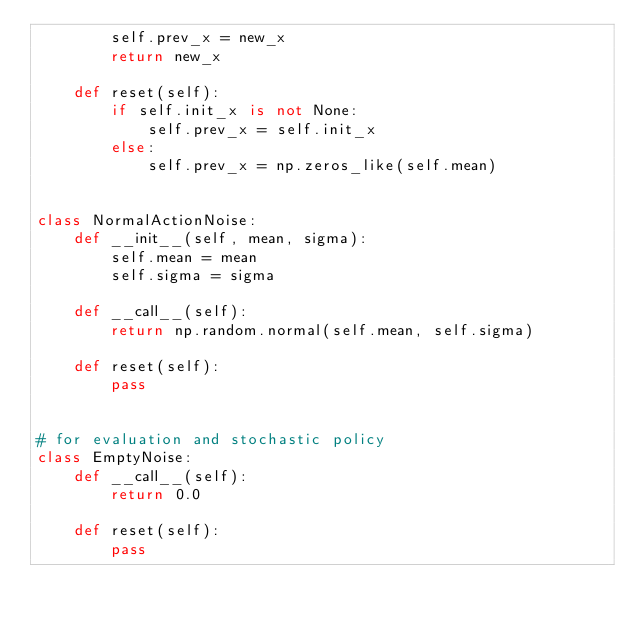Convert code to text. <code><loc_0><loc_0><loc_500><loc_500><_Python_>        self.prev_x = new_x
        return new_x

    def reset(self):
        if self.init_x is not None:
            self.prev_x = self.init_x
        else:
            self.prev_x = np.zeros_like(self.mean)


class NormalActionNoise:
    def __init__(self, mean, sigma):
        self.mean = mean
        self.sigma = sigma

    def __call__(self):
        return np.random.normal(self.mean, self.sigma)

    def reset(self):
        pass


# for evaluation and stochastic policy
class EmptyNoise:
    def __call__(self):
        return 0.0

    def reset(self):
        pass
</code> 